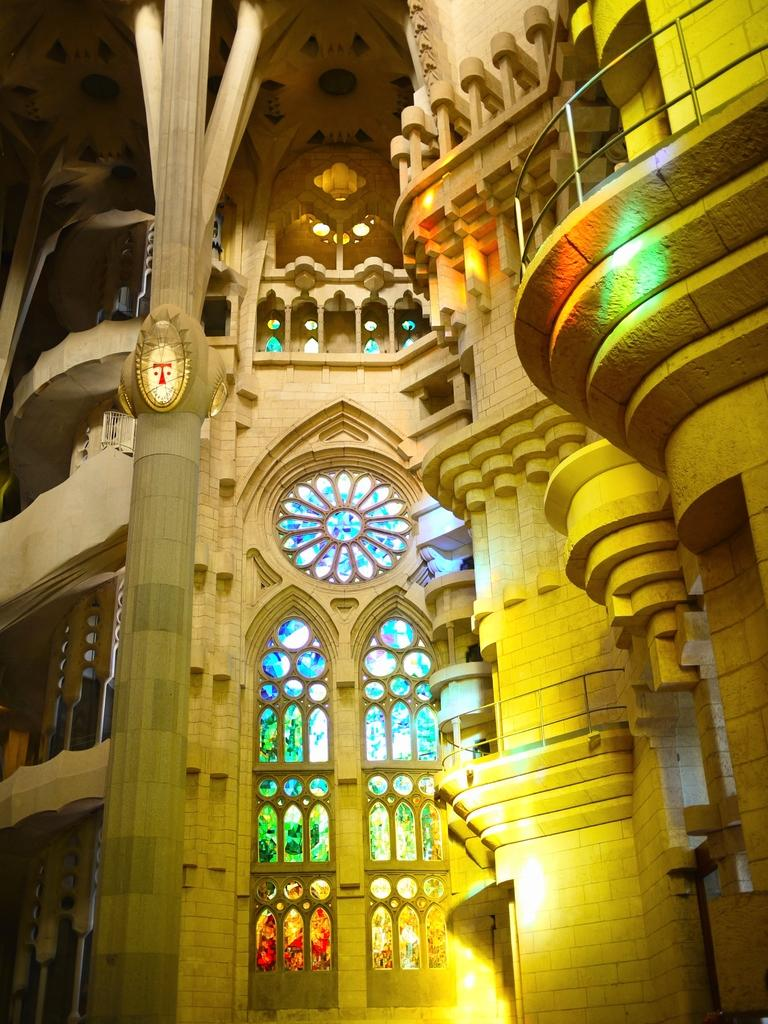What is the main structure in the image? There is a building in the image. What feature can be seen on the building? There are windows in the building. What else can be observed in the image? There are lights visible in the image. What is the condition of the kitten in the image? There is no kitten present in the image. How does the acoustics of the building affect the sound in the image? The provided facts do not mention anything about the acoustics of the building, so we cannot determine how it affects the sound in the image. 